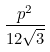Convert formula to latex. <formula><loc_0><loc_0><loc_500><loc_500>\frac { p ^ { 2 } } { 1 2 \sqrt { 3 } }</formula> 